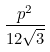Convert formula to latex. <formula><loc_0><loc_0><loc_500><loc_500>\frac { p ^ { 2 } } { 1 2 \sqrt { 3 } }</formula> 